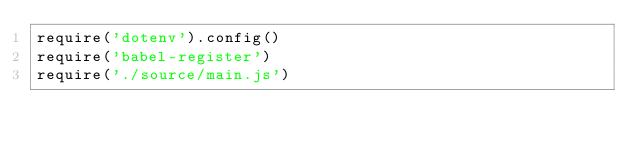Convert code to text. <code><loc_0><loc_0><loc_500><loc_500><_JavaScript_>require('dotenv').config()
require('babel-register')
require('./source/main.js')</code> 